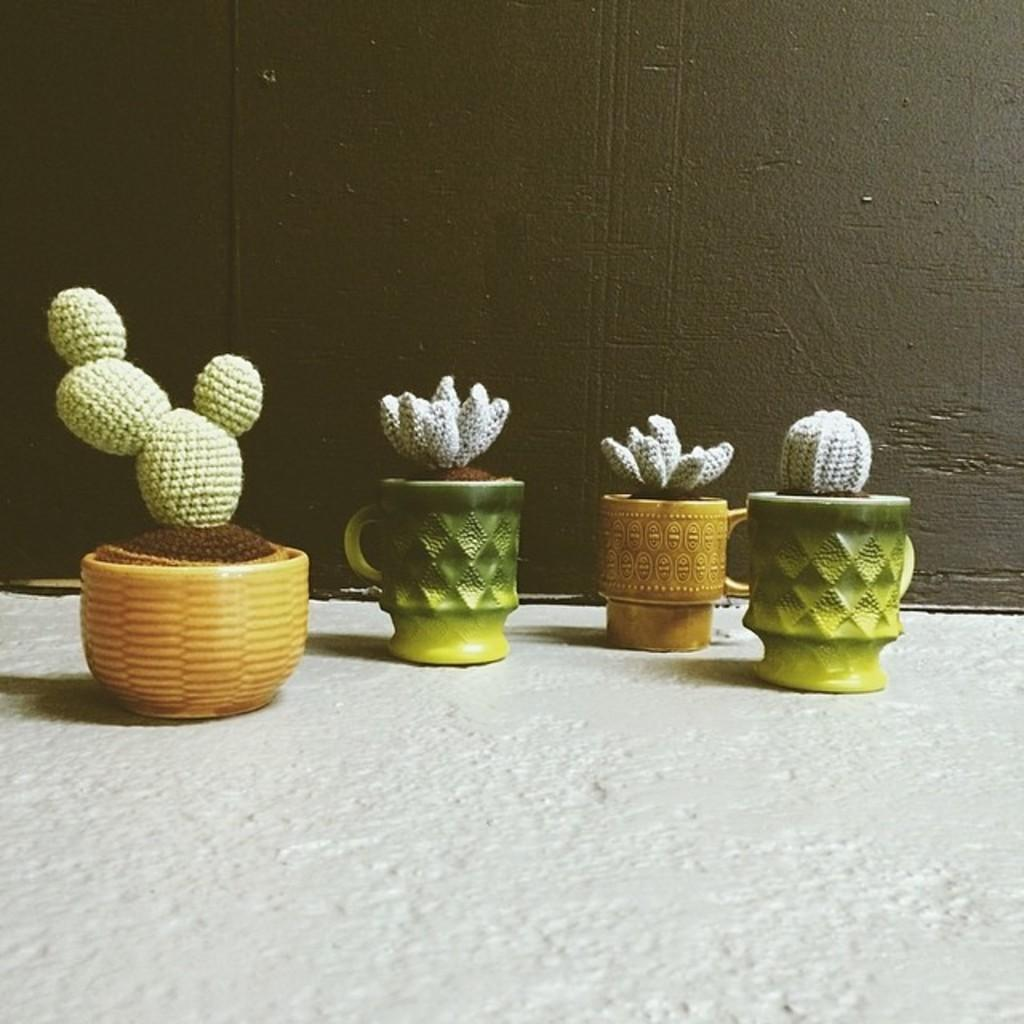What type of plants are on the floor in the image? There are cactus plants on the floor in the image. What is visible behind the cactus plants in the image? There is a wall visible at the back side of the image. Can you see a lawyer tying a knot in the grass in the image? There is no lawyer or grass present in the image, and therefore no such activity can be observed. 